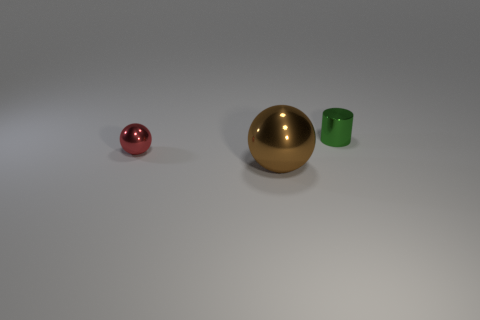Imagine if these objects were part of a larger scene—what kind of environment could they belong to? If these objects were part of a larger scene, they might belong in a contemporary art installation or a minimalist living space. Their simple geometric shapes and varied materials could also position them as educational tools in a classroom setting, where they could be used to teach about geometry, physics, or materials science. 